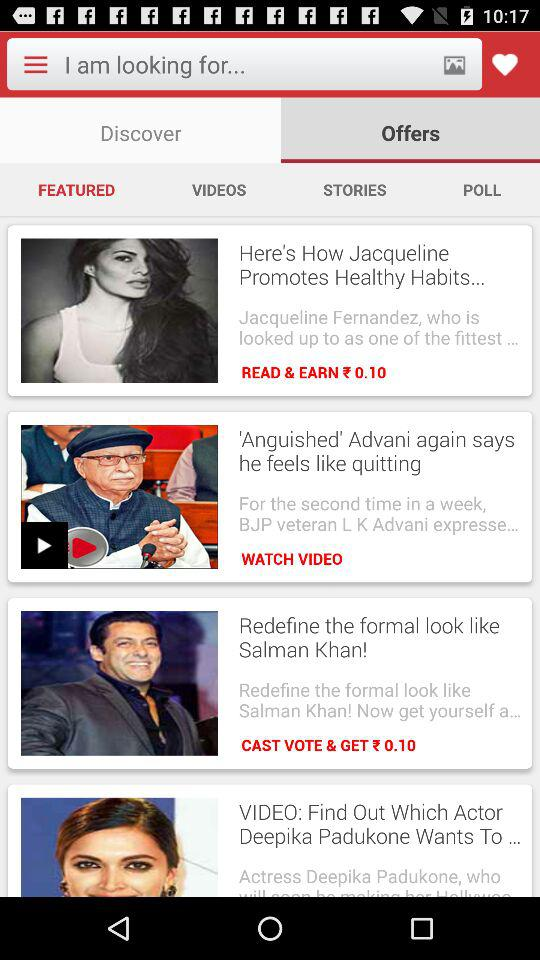Which category of videos are selected?
When the provided information is insufficient, respond with <no answer>. <no answer> 